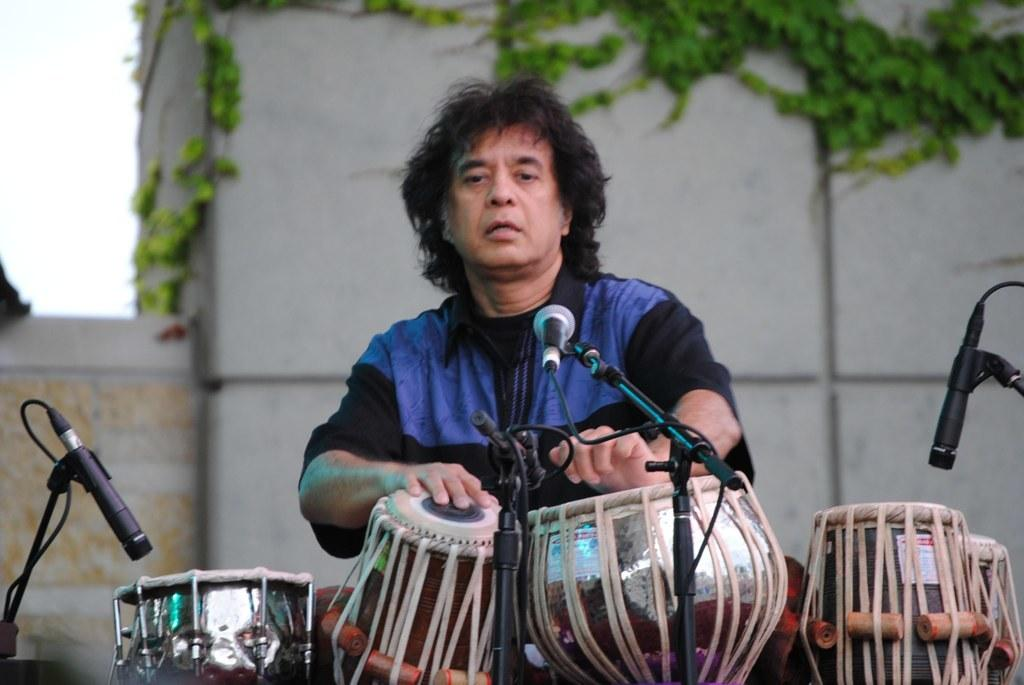What is the person in the image doing? The person in the image is playing drums. What instruments are visible in the image? There are drums visible in the image. What devices are present for amplifying sound? There are microphones (mics) in the image. What type of structure is in the background of the image? There is a building in the image. What type of vegetation is present on the building? Plants are visible on the building. How many spiders are crawling on the person playing drums in the image? There are no spiders visible in the image; it only shows a person playing drums, drums, microphones, a building, and plants on the building. 